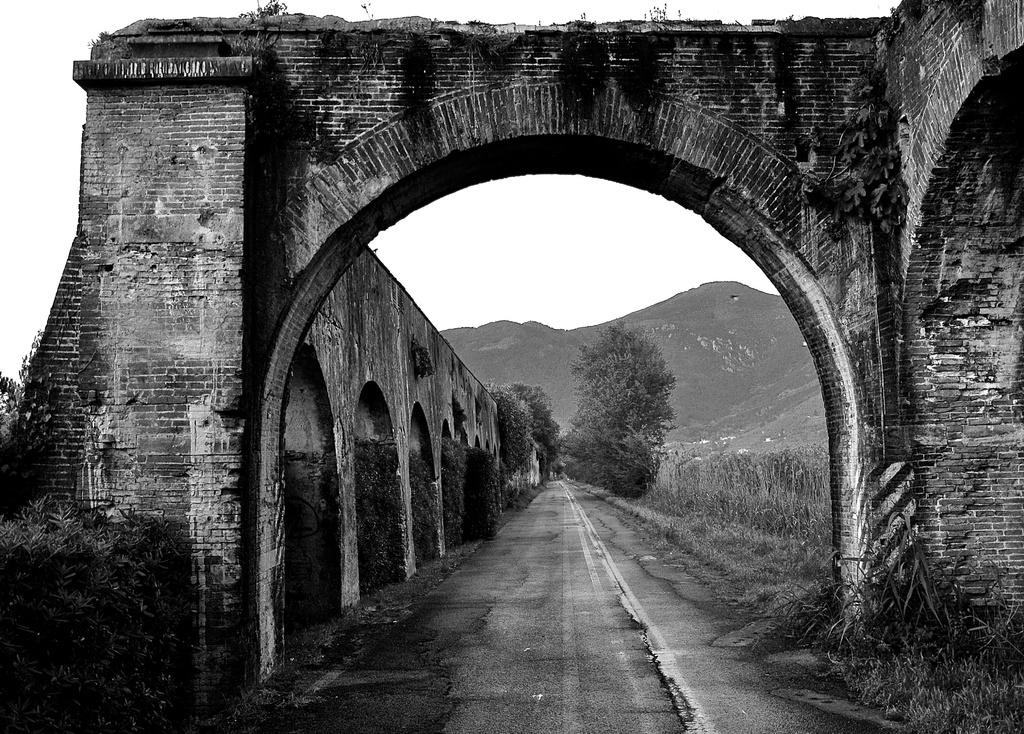What is the main feature of the image? There is a road in the image. What else can be seen in the image besides the road? There are constructions and a tree in the middle of the image. What is visible at the top of the image? The sky is visible at the top of the image. Can you tell me how many bags of popcorn are being carried by the rabbit in the image? There is no rabbit or popcorn present in the image. How many passengers are visible in the image? There is no reference to passengers in the image, as it features a road, constructions, a tree, and the sky. 